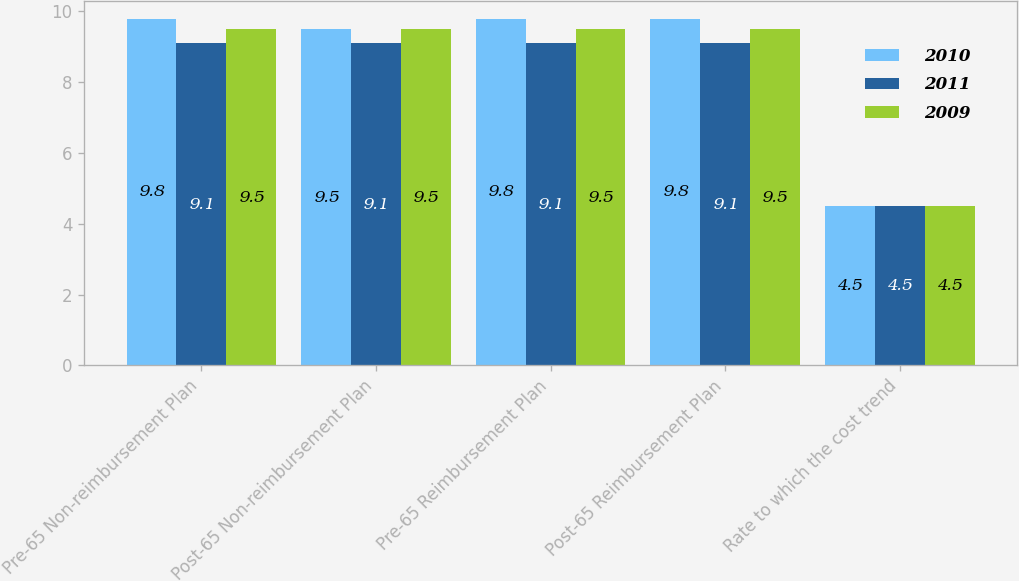<chart> <loc_0><loc_0><loc_500><loc_500><stacked_bar_chart><ecel><fcel>Pre-65 Non-reimbursement Plan<fcel>Post-65 Non-reimbursement Plan<fcel>Pre-65 Reimbursement Plan<fcel>Post-65 Reimbursement Plan<fcel>Rate to which the cost trend<nl><fcel>2010<fcel>9.8<fcel>9.5<fcel>9.8<fcel>9.8<fcel>4.5<nl><fcel>2011<fcel>9.1<fcel>9.1<fcel>9.1<fcel>9.1<fcel>4.5<nl><fcel>2009<fcel>9.5<fcel>9.5<fcel>9.5<fcel>9.5<fcel>4.5<nl></chart> 